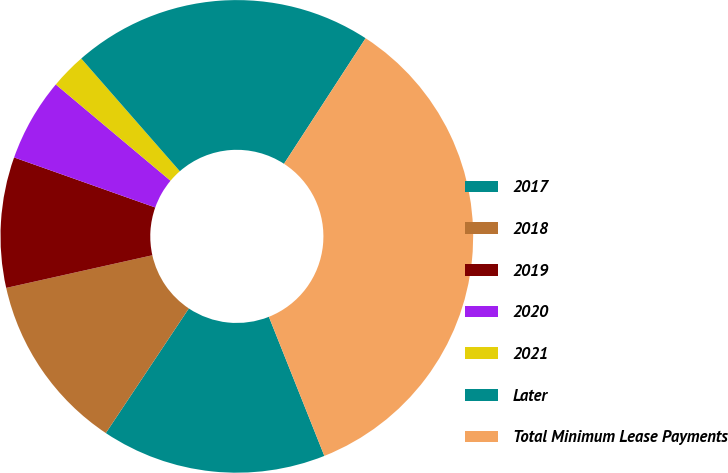Convert chart. <chart><loc_0><loc_0><loc_500><loc_500><pie_chart><fcel>2017<fcel>2018<fcel>2019<fcel>2020<fcel>2021<fcel>Later<fcel>Total Minimum Lease Payments<nl><fcel>15.39%<fcel>12.15%<fcel>8.92%<fcel>5.69%<fcel>2.45%<fcel>20.61%<fcel>34.79%<nl></chart> 